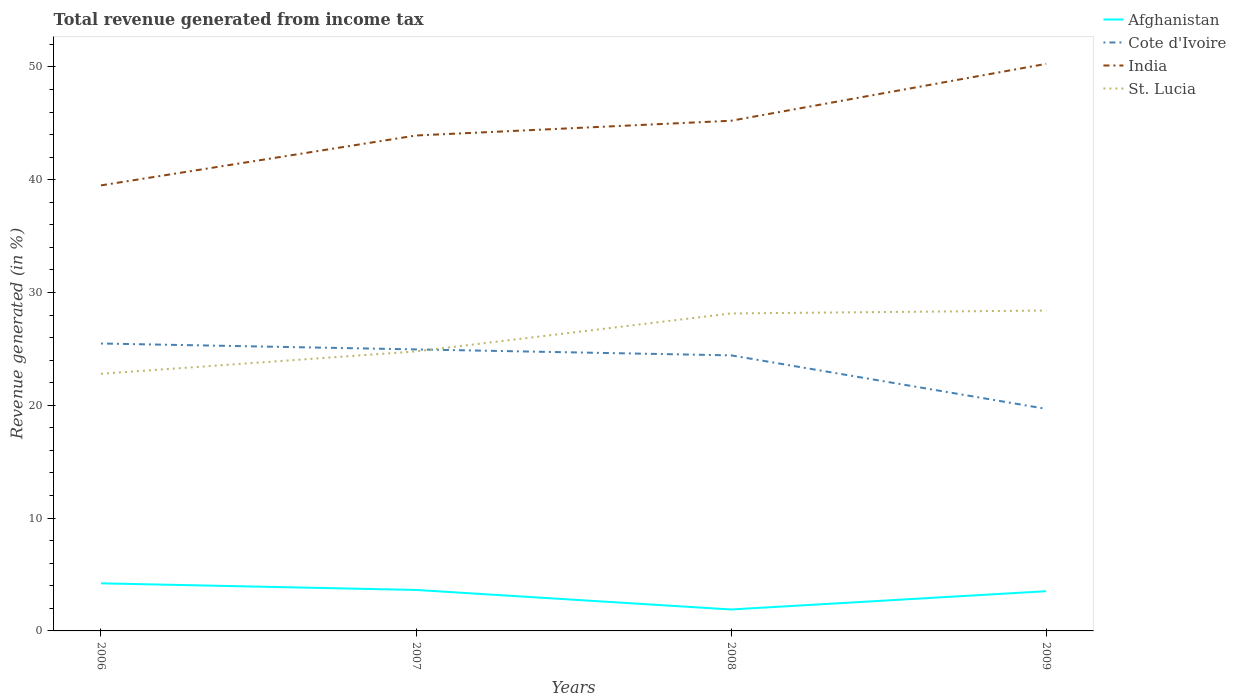Does the line corresponding to St. Lucia intersect with the line corresponding to Afghanistan?
Your answer should be compact. No. Is the number of lines equal to the number of legend labels?
Provide a succinct answer. Yes. Across all years, what is the maximum total revenue generated in India?
Offer a very short reply. 39.5. In which year was the total revenue generated in Afghanistan maximum?
Your answer should be very brief. 2008. What is the total total revenue generated in Afghanistan in the graph?
Make the answer very short. 0.11. What is the difference between the highest and the second highest total revenue generated in St. Lucia?
Keep it short and to the point. 5.61. What is the difference between the highest and the lowest total revenue generated in India?
Ensure brevity in your answer.  2. How many lines are there?
Ensure brevity in your answer.  4. What is the difference between two consecutive major ticks on the Y-axis?
Provide a short and direct response. 10. What is the title of the graph?
Your response must be concise. Total revenue generated from income tax. What is the label or title of the Y-axis?
Make the answer very short. Revenue generated (in %). What is the Revenue generated (in %) in Afghanistan in 2006?
Ensure brevity in your answer.  4.22. What is the Revenue generated (in %) of Cote d'Ivoire in 2006?
Offer a terse response. 25.48. What is the Revenue generated (in %) of India in 2006?
Your answer should be very brief. 39.5. What is the Revenue generated (in %) in St. Lucia in 2006?
Your answer should be compact. 22.8. What is the Revenue generated (in %) in Afghanistan in 2007?
Provide a short and direct response. 3.63. What is the Revenue generated (in %) in Cote d'Ivoire in 2007?
Your answer should be very brief. 24.96. What is the Revenue generated (in %) in India in 2007?
Your answer should be very brief. 43.92. What is the Revenue generated (in %) in St. Lucia in 2007?
Offer a very short reply. 24.78. What is the Revenue generated (in %) of Afghanistan in 2008?
Your response must be concise. 1.9. What is the Revenue generated (in %) of Cote d'Ivoire in 2008?
Keep it short and to the point. 24.43. What is the Revenue generated (in %) of India in 2008?
Your answer should be compact. 45.23. What is the Revenue generated (in %) of St. Lucia in 2008?
Give a very brief answer. 28.15. What is the Revenue generated (in %) of Afghanistan in 2009?
Your answer should be very brief. 3.52. What is the Revenue generated (in %) of Cote d'Ivoire in 2009?
Provide a short and direct response. 19.69. What is the Revenue generated (in %) in India in 2009?
Your answer should be very brief. 50.27. What is the Revenue generated (in %) in St. Lucia in 2009?
Make the answer very short. 28.4. Across all years, what is the maximum Revenue generated (in %) of Afghanistan?
Offer a terse response. 4.22. Across all years, what is the maximum Revenue generated (in %) of Cote d'Ivoire?
Your response must be concise. 25.48. Across all years, what is the maximum Revenue generated (in %) in India?
Keep it short and to the point. 50.27. Across all years, what is the maximum Revenue generated (in %) in St. Lucia?
Ensure brevity in your answer.  28.4. Across all years, what is the minimum Revenue generated (in %) of Afghanistan?
Offer a terse response. 1.9. Across all years, what is the minimum Revenue generated (in %) in Cote d'Ivoire?
Your response must be concise. 19.69. Across all years, what is the minimum Revenue generated (in %) of India?
Offer a very short reply. 39.5. Across all years, what is the minimum Revenue generated (in %) in St. Lucia?
Offer a very short reply. 22.8. What is the total Revenue generated (in %) of Afghanistan in the graph?
Give a very brief answer. 13.27. What is the total Revenue generated (in %) of Cote d'Ivoire in the graph?
Your answer should be compact. 94.55. What is the total Revenue generated (in %) in India in the graph?
Your answer should be very brief. 178.92. What is the total Revenue generated (in %) in St. Lucia in the graph?
Your answer should be compact. 104.12. What is the difference between the Revenue generated (in %) of Afghanistan in 2006 and that in 2007?
Ensure brevity in your answer.  0.59. What is the difference between the Revenue generated (in %) of Cote d'Ivoire in 2006 and that in 2007?
Give a very brief answer. 0.52. What is the difference between the Revenue generated (in %) in India in 2006 and that in 2007?
Provide a succinct answer. -4.42. What is the difference between the Revenue generated (in %) in St. Lucia in 2006 and that in 2007?
Your response must be concise. -1.98. What is the difference between the Revenue generated (in %) in Afghanistan in 2006 and that in 2008?
Provide a short and direct response. 2.32. What is the difference between the Revenue generated (in %) of Cote d'Ivoire in 2006 and that in 2008?
Your response must be concise. 1.05. What is the difference between the Revenue generated (in %) in India in 2006 and that in 2008?
Ensure brevity in your answer.  -5.73. What is the difference between the Revenue generated (in %) in St. Lucia in 2006 and that in 2008?
Your answer should be very brief. -5.35. What is the difference between the Revenue generated (in %) in Afghanistan in 2006 and that in 2009?
Your answer should be very brief. 0.7. What is the difference between the Revenue generated (in %) in Cote d'Ivoire in 2006 and that in 2009?
Your response must be concise. 5.79. What is the difference between the Revenue generated (in %) of India in 2006 and that in 2009?
Offer a very short reply. -10.77. What is the difference between the Revenue generated (in %) of St. Lucia in 2006 and that in 2009?
Give a very brief answer. -5.61. What is the difference between the Revenue generated (in %) of Afghanistan in 2007 and that in 2008?
Give a very brief answer. 1.73. What is the difference between the Revenue generated (in %) in Cote d'Ivoire in 2007 and that in 2008?
Offer a very short reply. 0.53. What is the difference between the Revenue generated (in %) of India in 2007 and that in 2008?
Provide a short and direct response. -1.31. What is the difference between the Revenue generated (in %) of St. Lucia in 2007 and that in 2008?
Give a very brief answer. -3.37. What is the difference between the Revenue generated (in %) in Afghanistan in 2007 and that in 2009?
Provide a short and direct response. 0.11. What is the difference between the Revenue generated (in %) of Cote d'Ivoire in 2007 and that in 2009?
Provide a succinct answer. 5.27. What is the difference between the Revenue generated (in %) in India in 2007 and that in 2009?
Give a very brief answer. -6.35. What is the difference between the Revenue generated (in %) of St. Lucia in 2007 and that in 2009?
Provide a short and direct response. -3.62. What is the difference between the Revenue generated (in %) of Afghanistan in 2008 and that in 2009?
Give a very brief answer. -1.62. What is the difference between the Revenue generated (in %) in Cote d'Ivoire in 2008 and that in 2009?
Your response must be concise. 4.74. What is the difference between the Revenue generated (in %) of India in 2008 and that in 2009?
Offer a terse response. -5.04. What is the difference between the Revenue generated (in %) of St. Lucia in 2008 and that in 2009?
Ensure brevity in your answer.  -0.26. What is the difference between the Revenue generated (in %) of Afghanistan in 2006 and the Revenue generated (in %) of Cote d'Ivoire in 2007?
Your response must be concise. -20.74. What is the difference between the Revenue generated (in %) of Afghanistan in 2006 and the Revenue generated (in %) of India in 2007?
Your answer should be very brief. -39.7. What is the difference between the Revenue generated (in %) in Afghanistan in 2006 and the Revenue generated (in %) in St. Lucia in 2007?
Ensure brevity in your answer.  -20.56. What is the difference between the Revenue generated (in %) in Cote d'Ivoire in 2006 and the Revenue generated (in %) in India in 2007?
Provide a succinct answer. -18.44. What is the difference between the Revenue generated (in %) of Cote d'Ivoire in 2006 and the Revenue generated (in %) of St. Lucia in 2007?
Ensure brevity in your answer.  0.7. What is the difference between the Revenue generated (in %) in India in 2006 and the Revenue generated (in %) in St. Lucia in 2007?
Your answer should be very brief. 14.72. What is the difference between the Revenue generated (in %) of Afghanistan in 2006 and the Revenue generated (in %) of Cote d'Ivoire in 2008?
Your answer should be compact. -20.21. What is the difference between the Revenue generated (in %) in Afghanistan in 2006 and the Revenue generated (in %) in India in 2008?
Your answer should be compact. -41.01. What is the difference between the Revenue generated (in %) in Afghanistan in 2006 and the Revenue generated (in %) in St. Lucia in 2008?
Your answer should be very brief. -23.93. What is the difference between the Revenue generated (in %) of Cote d'Ivoire in 2006 and the Revenue generated (in %) of India in 2008?
Provide a succinct answer. -19.75. What is the difference between the Revenue generated (in %) in Cote d'Ivoire in 2006 and the Revenue generated (in %) in St. Lucia in 2008?
Your response must be concise. -2.67. What is the difference between the Revenue generated (in %) of India in 2006 and the Revenue generated (in %) of St. Lucia in 2008?
Ensure brevity in your answer.  11.35. What is the difference between the Revenue generated (in %) in Afghanistan in 2006 and the Revenue generated (in %) in Cote d'Ivoire in 2009?
Your answer should be very brief. -15.47. What is the difference between the Revenue generated (in %) of Afghanistan in 2006 and the Revenue generated (in %) of India in 2009?
Provide a succinct answer. -46.05. What is the difference between the Revenue generated (in %) in Afghanistan in 2006 and the Revenue generated (in %) in St. Lucia in 2009?
Offer a terse response. -24.18. What is the difference between the Revenue generated (in %) of Cote d'Ivoire in 2006 and the Revenue generated (in %) of India in 2009?
Provide a succinct answer. -24.79. What is the difference between the Revenue generated (in %) of Cote d'Ivoire in 2006 and the Revenue generated (in %) of St. Lucia in 2009?
Offer a terse response. -2.92. What is the difference between the Revenue generated (in %) of India in 2006 and the Revenue generated (in %) of St. Lucia in 2009?
Your answer should be very brief. 11.1. What is the difference between the Revenue generated (in %) in Afghanistan in 2007 and the Revenue generated (in %) in Cote d'Ivoire in 2008?
Your response must be concise. -20.8. What is the difference between the Revenue generated (in %) of Afghanistan in 2007 and the Revenue generated (in %) of India in 2008?
Your response must be concise. -41.6. What is the difference between the Revenue generated (in %) of Afghanistan in 2007 and the Revenue generated (in %) of St. Lucia in 2008?
Offer a very short reply. -24.51. What is the difference between the Revenue generated (in %) in Cote d'Ivoire in 2007 and the Revenue generated (in %) in India in 2008?
Keep it short and to the point. -20.27. What is the difference between the Revenue generated (in %) of Cote d'Ivoire in 2007 and the Revenue generated (in %) of St. Lucia in 2008?
Ensure brevity in your answer.  -3.19. What is the difference between the Revenue generated (in %) of India in 2007 and the Revenue generated (in %) of St. Lucia in 2008?
Make the answer very short. 15.78. What is the difference between the Revenue generated (in %) of Afghanistan in 2007 and the Revenue generated (in %) of Cote d'Ivoire in 2009?
Make the answer very short. -16.05. What is the difference between the Revenue generated (in %) in Afghanistan in 2007 and the Revenue generated (in %) in India in 2009?
Ensure brevity in your answer.  -46.64. What is the difference between the Revenue generated (in %) of Afghanistan in 2007 and the Revenue generated (in %) of St. Lucia in 2009?
Your response must be concise. -24.77. What is the difference between the Revenue generated (in %) of Cote d'Ivoire in 2007 and the Revenue generated (in %) of India in 2009?
Your response must be concise. -25.31. What is the difference between the Revenue generated (in %) of Cote d'Ivoire in 2007 and the Revenue generated (in %) of St. Lucia in 2009?
Offer a terse response. -3.44. What is the difference between the Revenue generated (in %) in India in 2007 and the Revenue generated (in %) in St. Lucia in 2009?
Offer a terse response. 15.52. What is the difference between the Revenue generated (in %) in Afghanistan in 2008 and the Revenue generated (in %) in Cote d'Ivoire in 2009?
Offer a terse response. -17.79. What is the difference between the Revenue generated (in %) of Afghanistan in 2008 and the Revenue generated (in %) of India in 2009?
Offer a terse response. -48.37. What is the difference between the Revenue generated (in %) in Afghanistan in 2008 and the Revenue generated (in %) in St. Lucia in 2009?
Ensure brevity in your answer.  -26.5. What is the difference between the Revenue generated (in %) in Cote d'Ivoire in 2008 and the Revenue generated (in %) in India in 2009?
Provide a succinct answer. -25.84. What is the difference between the Revenue generated (in %) in Cote d'Ivoire in 2008 and the Revenue generated (in %) in St. Lucia in 2009?
Offer a very short reply. -3.97. What is the difference between the Revenue generated (in %) in India in 2008 and the Revenue generated (in %) in St. Lucia in 2009?
Provide a short and direct response. 16.83. What is the average Revenue generated (in %) in Afghanistan per year?
Offer a very short reply. 3.32. What is the average Revenue generated (in %) in Cote d'Ivoire per year?
Keep it short and to the point. 23.64. What is the average Revenue generated (in %) of India per year?
Your answer should be very brief. 44.73. What is the average Revenue generated (in %) of St. Lucia per year?
Make the answer very short. 26.03. In the year 2006, what is the difference between the Revenue generated (in %) of Afghanistan and Revenue generated (in %) of Cote d'Ivoire?
Make the answer very short. -21.26. In the year 2006, what is the difference between the Revenue generated (in %) of Afghanistan and Revenue generated (in %) of India?
Your answer should be very brief. -35.28. In the year 2006, what is the difference between the Revenue generated (in %) in Afghanistan and Revenue generated (in %) in St. Lucia?
Provide a short and direct response. -18.58. In the year 2006, what is the difference between the Revenue generated (in %) of Cote d'Ivoire and Revenue generated (in %) of India?
Make the answer very short. -14.02. In the year 2006, what is the difference between the Revenue generated (in %) in Cote d'Ivoire and Revenue generated (in %) in St. Lucia?
Give a very brief answer. 2.68. In the year 2006, what is the difference between the Revenue generated (in %) in India and Revenue generated (in %) in St. Lucia?
Your answer should be compact. 16.7. In the year 2007, what is the difference between the Revenue generated (in %) in Afghanistan and Revenue generated (in %) in Cote d'Ivoire?
Ensure brevity in your answer.  -21.32. In the year 2007, what is the difference between the Revenue generated (in %) in Afghanistan and Revenue generated (in %) in India?
Provide a succinct answer. -40.29. In the year 2007, what is the difference between the Revenue generated (in %) of Afghanistan and Revenue generated (in %) of St. Lucia?
Offer a very short reply. -21.15. In the year 2007, what is the difference between the Revenue generated (in %) in Cote d'Ivoire and Revenue generated (in %) in India?
Your answer should be very brief. -18.96. In the year 2007, what is the difference between the Revenue generated (in %) in Cote d'Ivoire and Revenue generated (in %) in St. Lucia?
Your response must be concise. 0.18. In the year 2007, what is the difference between the Revenue generated (in %) in India and Revenue generated (in %) in St. Lucia?
Your answer should be very brief. 19.14. In the year 2008, what is the difference between the Revenue generated (in %) of Afghanistan and Revenue generated (in %) of Cote d'Ivoire?
Provide a short and direct response. -22.53. In the year 2008, what is the difference between the Revenue generated (in %) in Afghanistan and Revenue generated (in %) in India?
Provide a succinct answer. -43.33. In the year 2008, what is the difference between the Revenue generated (in %) of Afghanistan and Revenue generated (in %) of St. Lucia?
Your answer should be compact. -26.25. In the year 2008, what is the difference between the Revenue generated (in %) in Cote d'Ivoire and Revenue generated (in %) in India?
Your response must be concise. -20.8. In the year 2008, what is the difference between the Revenue generated (in %) of Cote d'Ivoire and Revenue generated (in %) of St. Lucia?
Provide a short and direct response. -3.72. In the year 2008, what is the difference between the Revenue generated (in %) in India and Revenue generated (in %) in St. Lucia?
Your answer should be very brief. 17.08. In the year 2009, what is the difference between the Revenue generated (in %) in Afghanistan and Revenue generated (in %) in Cote d'Ivoire?
Make the answer very short. -16.17. In the year 2009, what is the difference between the Revenue generated (in %) of Afghanistan and Revenue generated (in %) of India?
Your answer should be compact. -46.75. In the year 2009, what is the difference between the Revenue generated (in %) in Afghanistan and Revenue generated (in %) in St. Lucia?
Keep it short and to the point. -24.88. In the year 2009, what is the difference between the Revenue generated (in %) in Cote d'Ivoire and Revenue generated (in %) in India?
Your response must be concise. -30.58. In the year 2009, what is the difference between the Revenue generated (in %) of Cote d'Ivoire and Revenue generated (in %) of St. Lucia?
Provide a short and direct response. -8.71. In the year 2009, what is the difference between the Revenue generated (in %) of India and Revenue generated (in %) of St. Lucia?
Keep it short and to the point. 21.87. What is the ratio of the Revenue generated (in %) in Afghanistan in 2006 to that in 2007?
Keep it short and to the point. 1.16. What is the ratio of the Revenue generated (in %) of Cote d'Ivoire in 2006 to that in 2007?
Offer a very short reply. 1.02. What is the ratio of the Revenue generated (in %) of India in 2006 to that in 2007?
Offer a terse response. 0.9. What is the ratio of the Revenue generated (in %) in Afghanistan in 2006 to that in 2008?
Provide a short and direct response. 2.22. What is the ratio of the Revenue generated (in %) in Cote d'Ivoire in 2006 to that in 2008?
Provide a succinct answer. 1.04. What is the ratio of the Revenue generated (in %) in India in 2006 to that in 2008?
Your answer should be compact. 0.87. What is the ratio of the Revenue generated (in %) in St. Lucia in 2006 to that in 2008?
Keep it short and to the point. 0.81. What is the ratio of the Revenue generated (in %) in Afghanistan in 2006 to that in 2009?
Provide a succinct answer. 1.2. What is the ratio of the Revenue generated (in %) in Cote d'Ivoire in 2006 to that in 2009?
Offer a very short reply. 1.29. What is the ratio of the Revenue generated (in %) of India in 2006 to that in 2009?
Provide a succinct answer. 0.79. What is the ratio of the Revenue generated (in %) of St. Lucia in 2006 to that in 2009?
Your answer should be compact. 0.8. What is the ratio of the Revenue generated (in %) in Afghanistan in 2007 to that in 2008?
Offer a terse response. 1.91. What is the ratio of the Revenue generated (in %) of Cote d'Ivoire in 2007 to that in 2008?
Give a very brief answer. 1.02. What is the ratio of the Revenue generated (in %) in India in 2007 to that in 2008?
Offer a terse response. 0.97. What is the ratio of the Revenue generated (in %) in St. Lucia in 2007 to that in 2008?
Your response must be concise. 0.88. What is the ratio of the Revenue generated (in %) of Afghanistan in 2007 to that in 2009?
Provide a succinct answer. 1.03. What is the ratio of the Revenue generated (in %) of Cote d'Ivoire in 2007 to that in 2009?
Your response must be concise. 1.27. What is the ratio of the Revenue generated (in %) in India in 2007 to that in 2009?
Make the answer very short. 0.87. What is the ratio of the Revenue generated (in %) in St. Lucia in 2007 to that in 2009?
Make the answer very short. 0.87. What is the ratio of the Revenue generated (in %) in Afghanistan in 2008 to that in 2009?
Your response must be concise. 0.54. What is the ratio of the Revenue generated (in %) in Cote d'Ivoire in 2008 to that in 2009?
Your answer should be compact. 1.24. What is the ratio of the Revenue generated (in %) in India in 2008 to that in 2009?
Ensure brevity in your answer.  0.9. What is the ratio of the Revenue generated (in %) in St. Lucia in 2008 to that in 2009?
Ensure brevity in your answer.  0.99. What is the difference between the highest and the second highest Revenue generated (in %) in Afghanistan?
Make the answer very short. 0.59. What is the difference between the highest and the second highest Revenue generated (in %) in Cote d'Ivoire?
Offer a terse response. 0.52. What is the difference between the highest and the second highest Revenue generated (in %) in India?
Ensure brevity in your answer.  5.04. What is the difference between the highest and the second highest Revenue generated (in %) of St. Lucia?
Your response must be concise. 0.26. What is the difference between the highest and the lowest Revenue generated (in %) in Afghanistan?
Offer a terse response. 2.32. What is the difference between the highest and the lowest Revenue generated (in %) of Cote d'Ivoire?
Your response must be concise. 5.79. What is the difference between the highest and the lowest Revenue generated (in %) in India?
Make the answer very short. 10.77. What is the difference between the highest and the lowest Revenue generated (in %) in St. Lucia?
Ensure brevity in your answer.  5.61. 